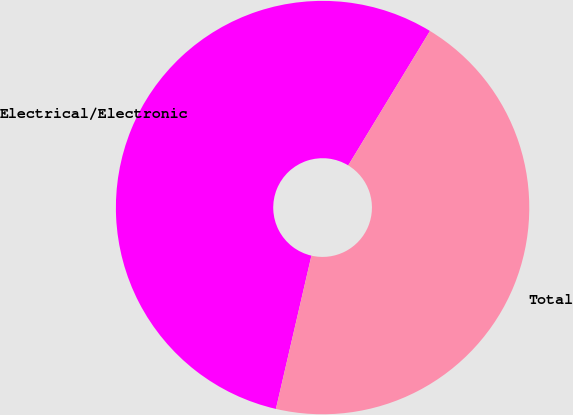Convert chart to OTSL. <chart><loc_0><loc_0><loc_500><loc_500><pie_chart><fcel>Electrical/Electronic<fcel>Total<nl><fcel>55.07%<fcel>44.93%<nl></chart> 